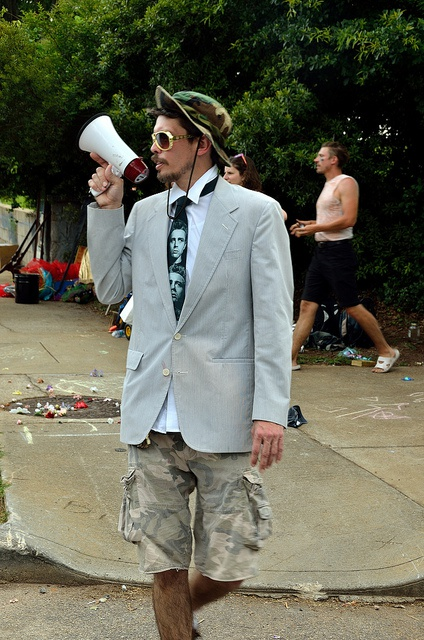Describe the objects in this image and their specific colors. I can see people in black, darkgray, gray, and lightblue tones, people in black, gray, and maroon tones, tie in black, lightblue, teal, and gray tones, and people in black, gray, maroon, and tan tones in this image. 